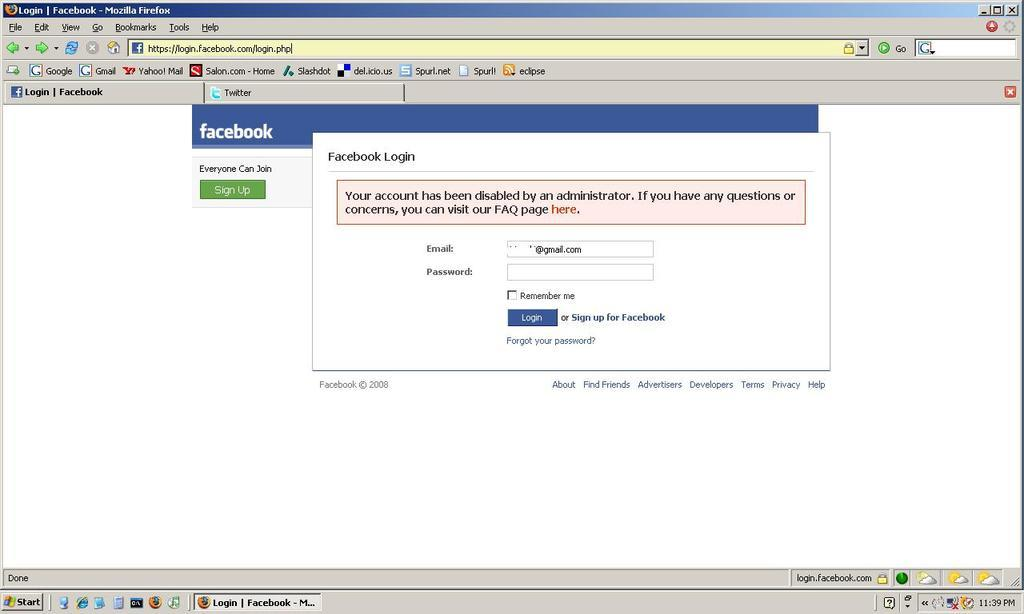<image>
Present a compact description of the photo's key features. a computer screen shot open to the Facebook Sign up page 